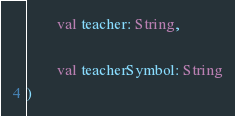<code> <loc_0><loc_0><loc_500><loc_500><_Kotlin_>
        val teacher: String,

        val teacherSymbol: String
)
</code> 